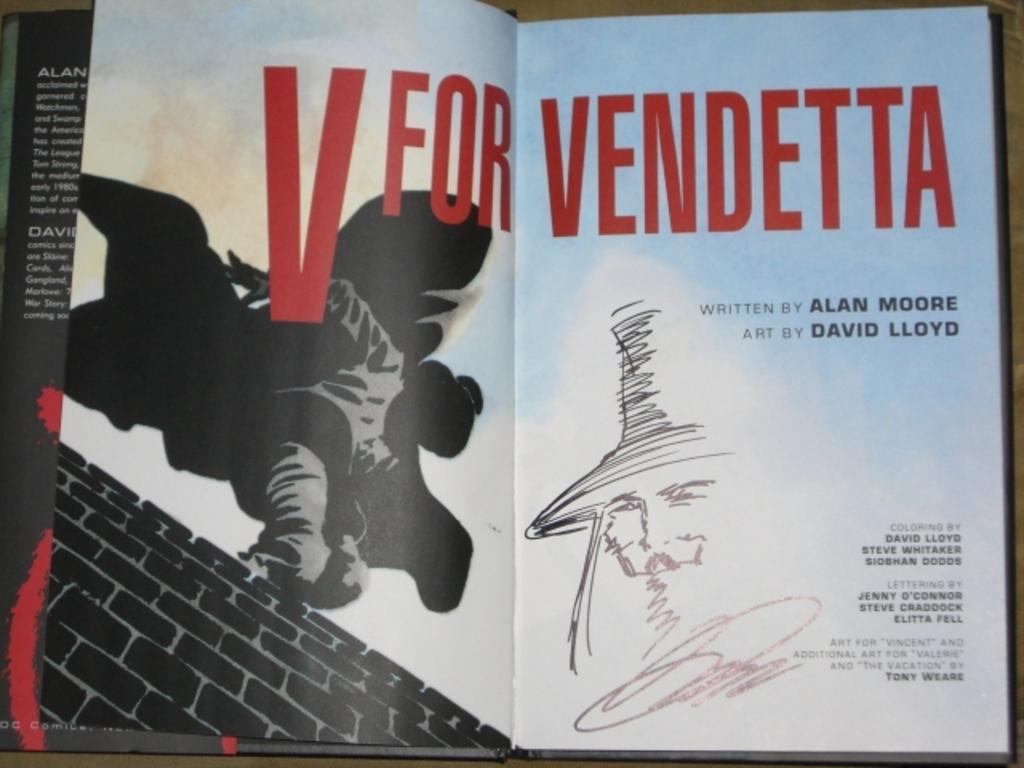Who wrote v for vendetta?
Provide a short and direct response. Alan moore. The book is called what?
Provide a short and direct response. V for vendetta. 